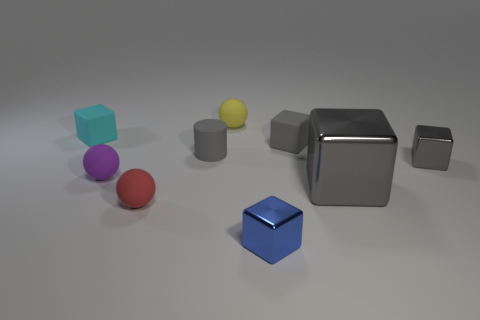There is a big cube; does it have the same color as the tiny rubber cube right of the yellow thing?
Keep it short and to the point. Yes. What material is the cylinder that is the same color as the large metallic object?
Provide a succinct answer. Rubber. What size is the other rubber block that is the same color as the large block?
Your answer should be compact. Small. Is the size of the metallic block in front of the red ball the same as the cube that is to the left of the tiny purple ball?
Ensure brevity in your answer.  Yes. What size is the matte block that is on the right side of the tiny gray matte cylinder?
Ensure brevity in your answer.  Small. Is there another big metal cube that has the same color as the large metal block?
Ensure brevity in your answer.  No. Are there any purple spheres behind the small cube that is right of the gray matte block?
Your answer should be compact. No. There is a rubber cylinder; does it have the same size as the matte block to the right of the blue object?
Provide a short and direct response. Yes. Is there a cylinder right of the matte cube that is to the right of the small rubber sphere behind the cyan block?
Give a very brief answer. No. There is a cube to the left of the tiny yellow thing; what is its material?
Provide a short and direct response. Rubber. 